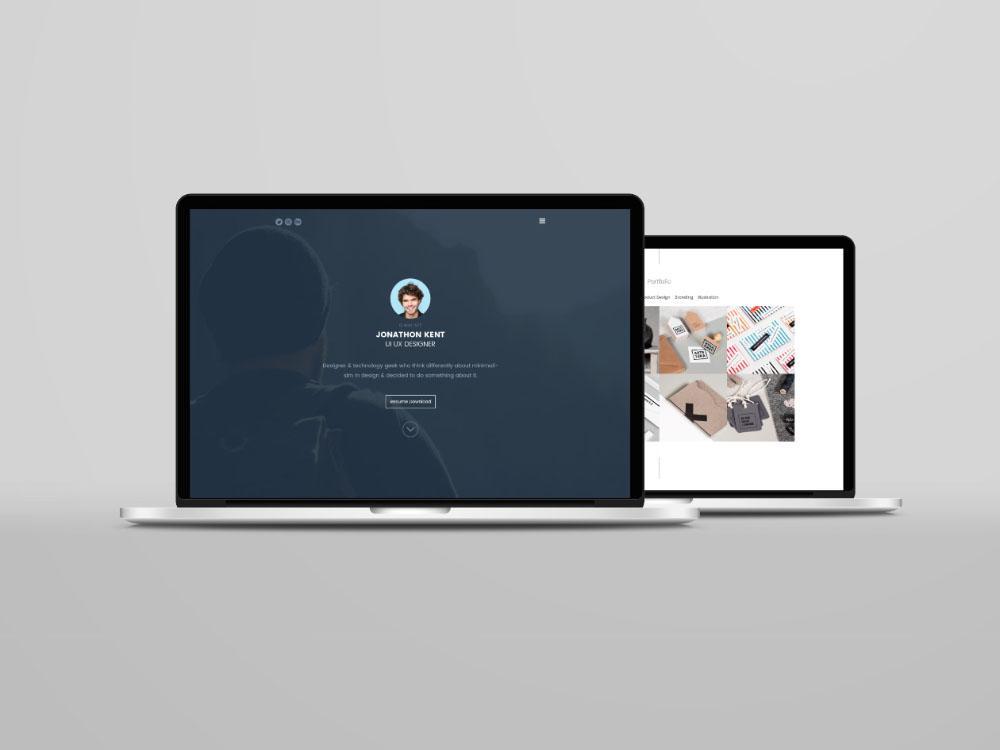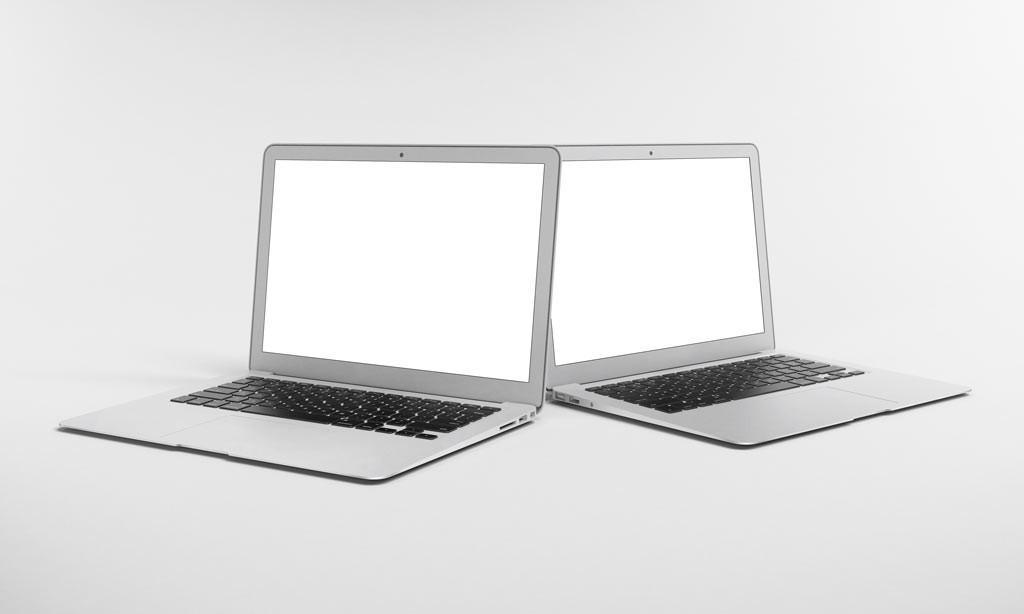The first image is the image on the left, the second image is the image on the right. Evaluate the accuracy of this statement regarding the images: "There are more devices in the image on the right.". Is it true? Answer yes or no. No. The first image is the image on the left, the second image is the image on the right. Considering the images on both sides, is "The left image shows exactly one open forward-facing laptop on a white table, and the right image shows one open, forward-facing laptop overlapping another open, forward-facing laptop." valid? Answer yes or no. No. 